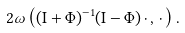Convert formula to latex. <formula><loc_0><loc_0><loc_500><loc_500>2 \omega \left ( ( \mathrm I + \Phi ) ^ { - 1 } ( \mathrm I - \Phi ) \, \cdot \, , \, \cdot \, \right ) .</formula> 